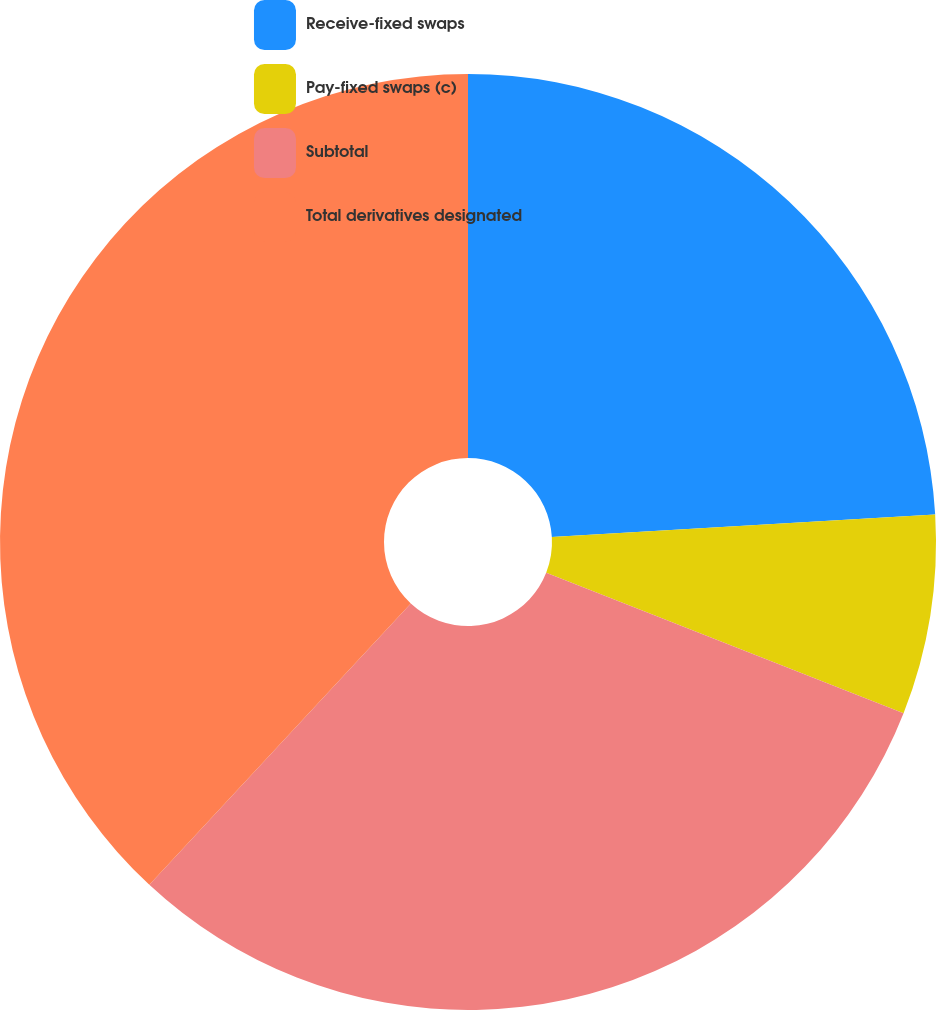Convert chart to OTSL. <chart><loc_0><loc_0><loc_500><loc_500><pie_chart><fcel>Receive-fixed swaps<fcel>Pay-fixed swaps (c)<fcel>Subtotal<fcel>Total derivatives designated<nl><fcel>24.06%<fcel>6.9%<fcel>30.96%<fcel>38.08%<nl></chart> 